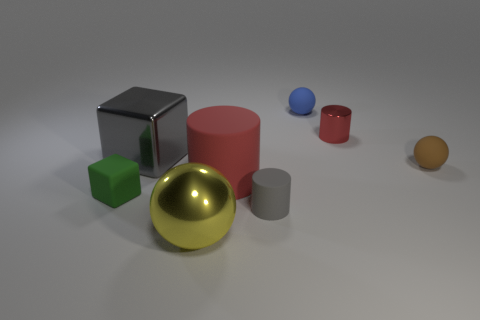Add 1 large blue metal balls. How many objects exist? 9 Subtract all balls. How many objects are left? 5 Add 7 shiny cylinders. How many shiny cylinders are left? 8 Add 3 tiny brown matte cylinders. How many tiny brown matte cylinders exist? 3 Subtract 0 brown cylinders. How many objects are left? 8 Subtract all shiny blocks. Subtract all blue spheres. How many objects are left? 6 